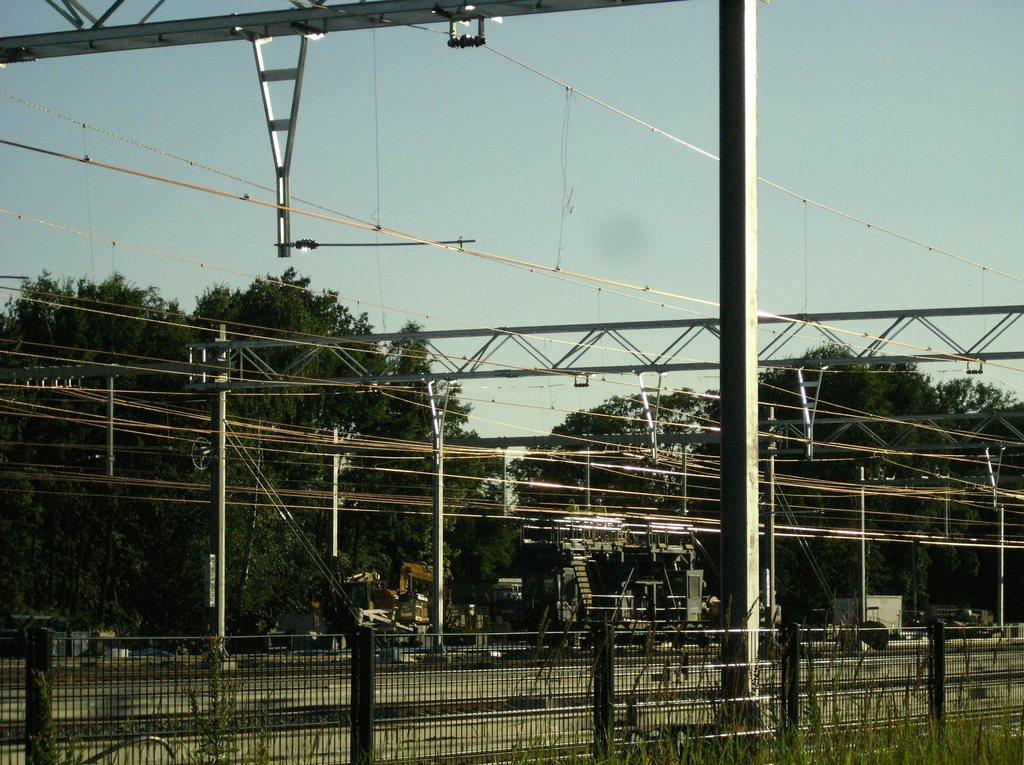How would you summarize this image in a sentence or two? In the picture I can see the electric poles and electric wires. I can see the metal grill fence and green grass at the bottom of the picture. In the background, I can see the trees. There are clouds in the sky. In the picture I can see the platform of a railway station. 